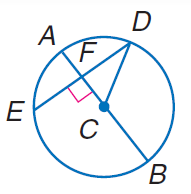Answer the mathemtical geometry problem and directly provide the correct option letter.
Question: If D E = 60 and F C = 16, find A B.
Choices: A: 16 B: 34 C: 60 D: 68 D 